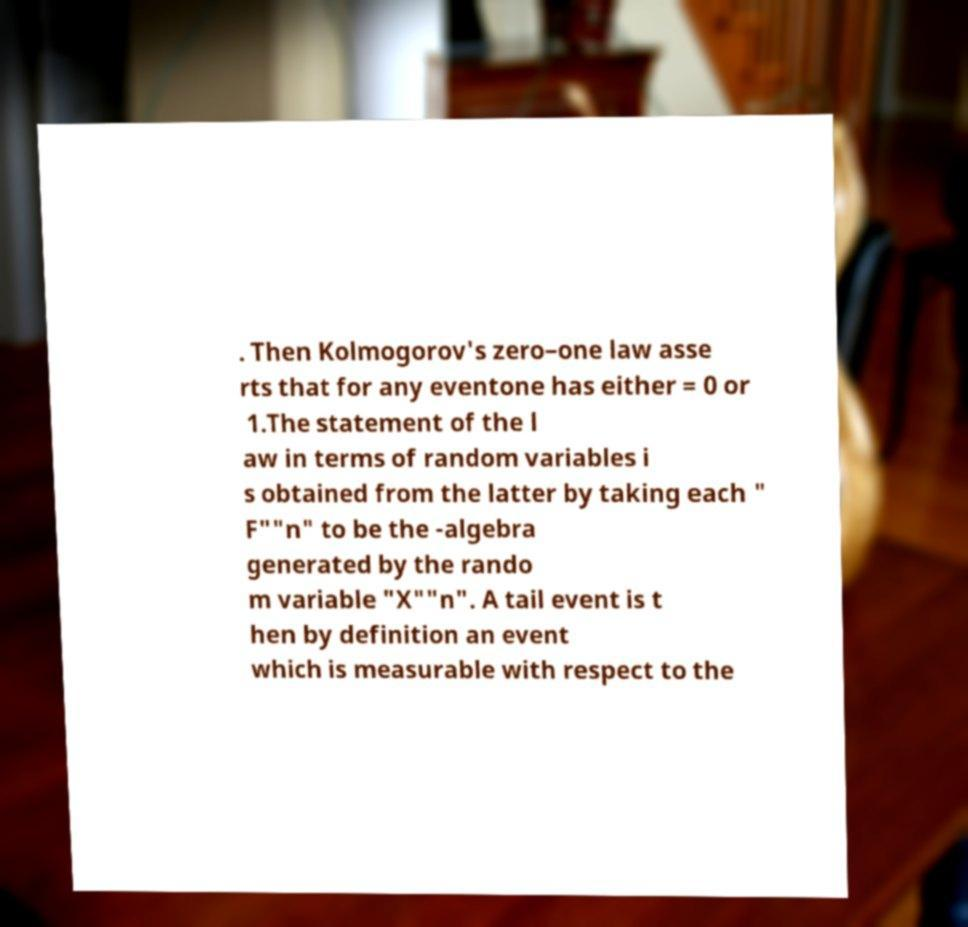For documentation purposes, I need the text within this image transcribed. Could you provide that? . Then Kolmogorov's zero–one law asse rts that for any eventone has either = 0 or 1.The statement of the l aw in terms of random variables i s obtained from the latter by taking each " F""n" to be the -algebra generated by the rando m variable "X""n". A tail event is t hen by definition an event which is measurable with respect to the 